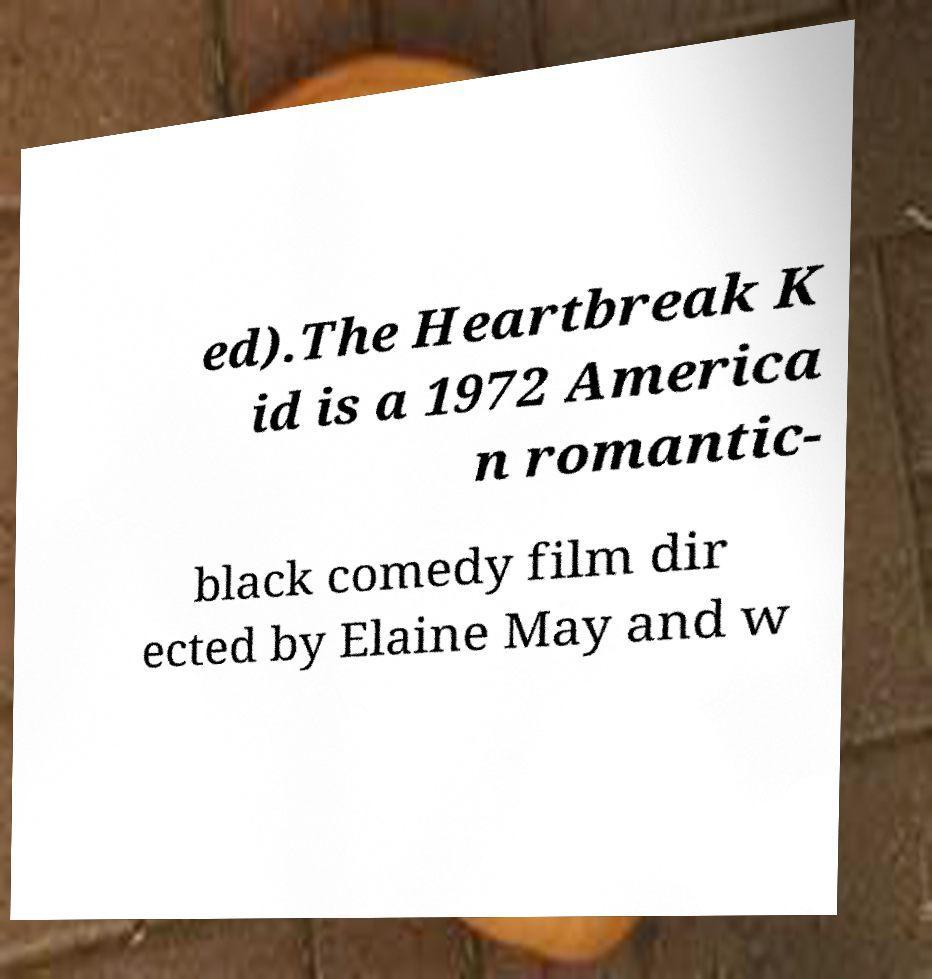Can you read and provide the text displayed in the image?This photo seems to have some interesting text. Can you extract and type it out for me? ed).The Heartbreak K id is a 1972 America n romantic- black comedy film dir ected by Elaine May and w 